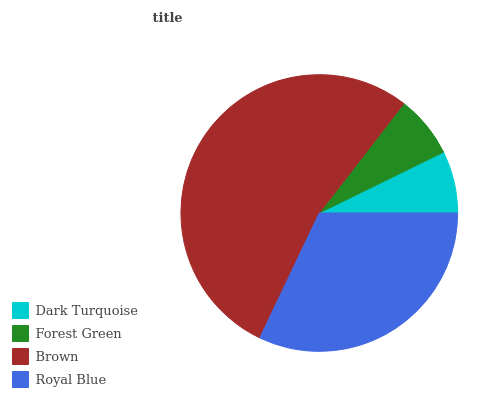Is Dark Turquoise the minimum?
Answer yes or no. Yes. Is Brown the maximum?
Answer yes or no. Yes. Is Forest Green the minimum?
Answer yes or no. No. Is Forest Green the maximum?
Answer yes or no. No. Is Forest Green greater than Dark Turquoise?
Answer yes or no. Yes. Is Dark Turquoise less than Forest Green?
Answer yes or no. Yes. Is Dark Turquoise greater than Forest Green?
Answer yes or no. No. Is Forest Green less than Dark Turquoise?
Answer yes or no. No. Is Royal Blue the high median?
Answer yes or no. Yes. Is Forest Green the low median?
Answer yes or no. Yes. Is Dark Turquoise the high median?
Answer yes or no. No. Is Brown the low median?
Answer yes or no. No. 